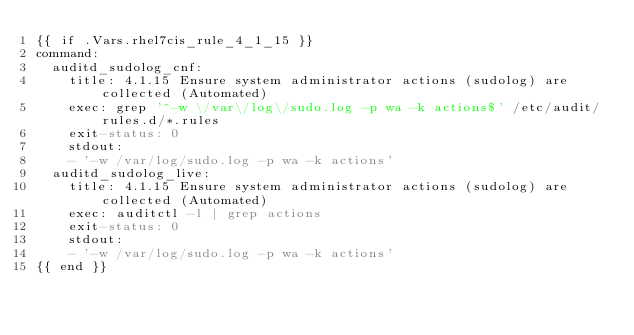<code> <loc_0><loc_0><loc_500><loc_500><_YAML_>{{ if .Vars.rhel7cis_rule_4_1_15 }}
command:
  auditd_sudolog_cnf:
    title: 4.1.15 Ensure system administrator actions (sudolog) are collected (Automated)
    exec: grep '^-w \/var\/log\/sudo.log -p wa -k actions$' /etc/audit/rules.d/*.rules
    exit-status: 0
    stdout:
    - '-w /var/log/sudo.log -p wa -k actions'
  auditd_sudolog_live:
    title: 4.1.15 Ensure system administrator actions (sudolog) are collected (Automated)
    exec: auditctl -l | grep actions
    exit-status: 0
    stdout:
    - '-w /var/log/sudo.log -p wa -k actions'
{{ end }}
</code> 